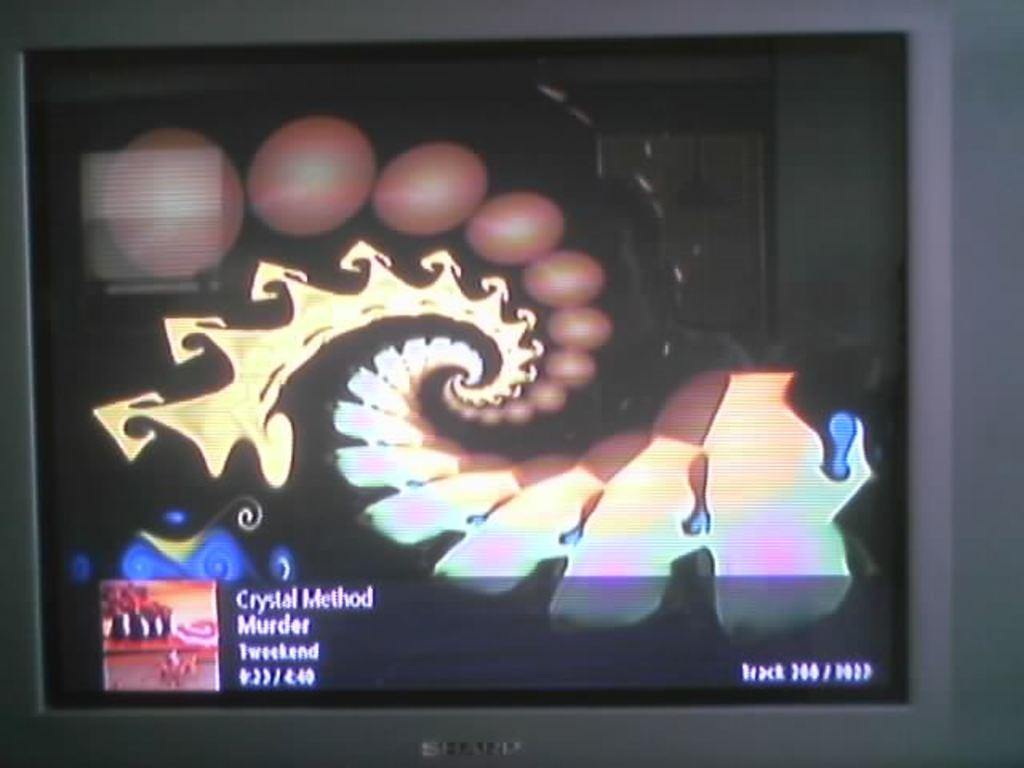<image>
Give a short and clear explanation of the subsequent image. A TV is showing a video from the band Crystal Method on the screen. 